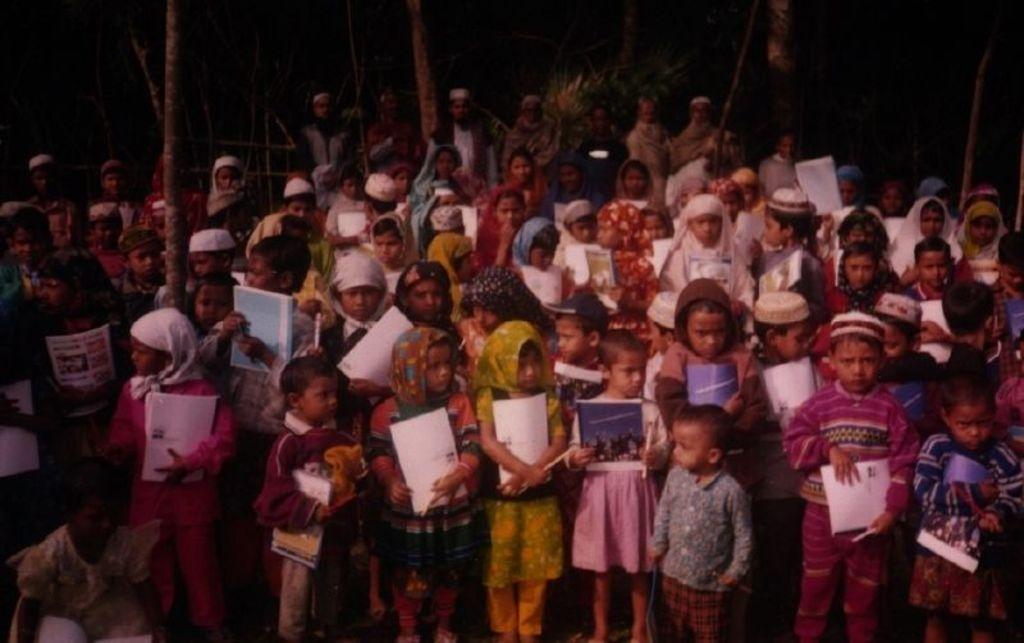What is the main subject of the image? The main subject of the image is a group of children. What are the children doing in the image? The children are standing in the image. What objects are the children holding in their hands? The children are holding books in their hands. What color of paint is being used by the children in the image? There is no paint present in the image; the children are holding books. Is there a pipe visible in the image? No, there is no pipe visible in the image. 